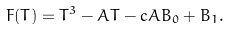<formula> <loc_0><loc_0><loc_500><loc_500>F ( T ) = T ^ { 3 } - A T - c A B _ { 0 } + B _ { 1 } .</formula> 